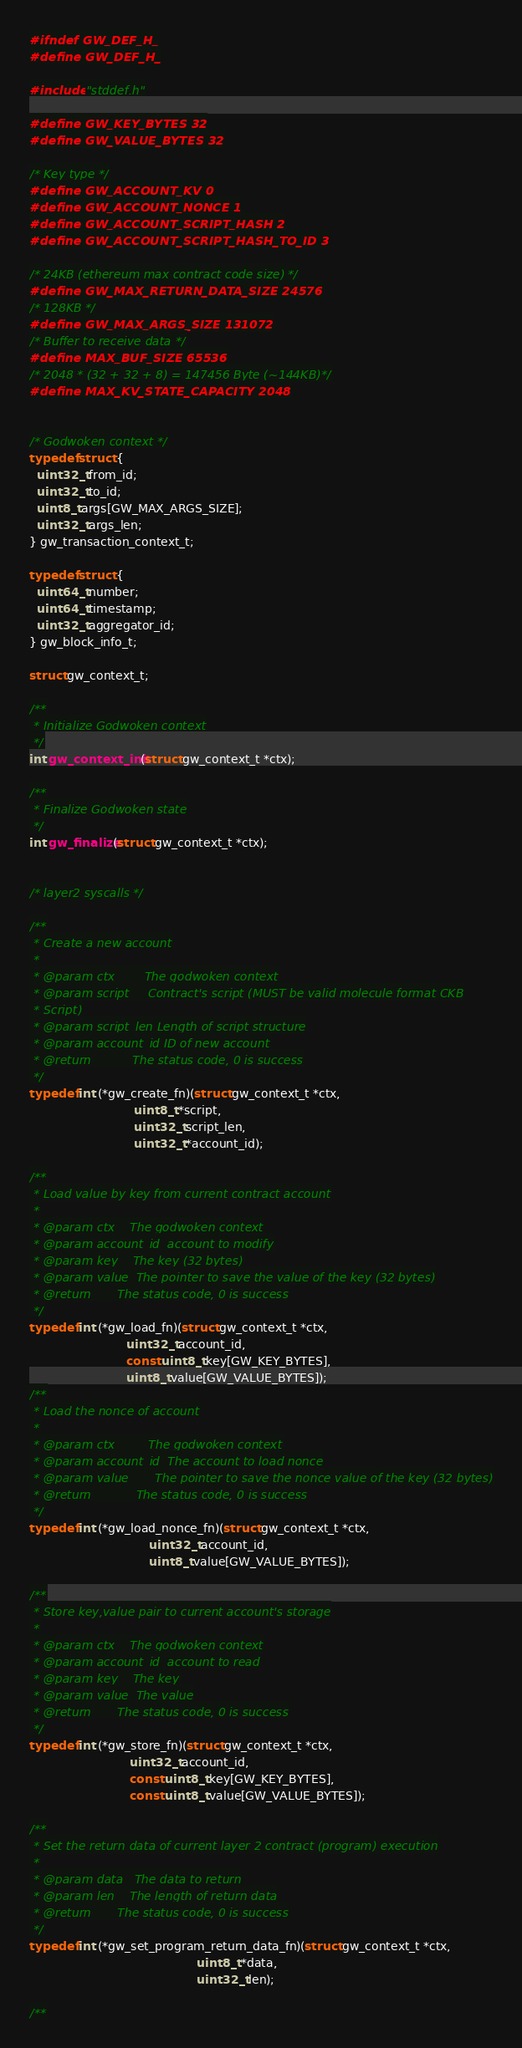<code> <loc_0><loc_0><loc_500><loc_500><_C_>#ifndef GW_DEF_H_
#define GW_DEF_H_

#include "stddef.h"

#define GW_KEY_BYTES 32
#define GW_VALUE_BYTES 32

/* Key type */
#define GW_ACCOUNT_KV 0
#define GW_ACCOUNT_NONCE 1
#define GW_ACCOUNT_SCRIPT_HASH 2
#define GW_ACCOUNT_SCRIPT_HASH_TO_ID 3

/* 24KB (ethereum max contract code size) */
#define GW_MAX_RETURN_DATA_SIZE 24576
/* 128KB */
#define GW_MAX_ARGS_SIZE 131072
/* Buffer to receive data */
#define MAX_BUF_SIZE 65536
/* 2048 * (32 + 32 + 8) = 147456 Byte (~144KB)*/
#define MAX_KV_STATE_CAPACITY 2048


/* Godwoken context */
typedef struct {
  uint32_t from_id;
  uint32_t to_id;
  uint8_t args[GW_MAX_ARGS_SIZE];
  uint32_t args_len;
} gw_transaction_context_t;

typedef struct {
  uint64_t number;
  uint64_t timestamp;
  uint32_t aggregator_id;
} gw_block_info_t;

struct gw_context_t;

/**
 * Initialize Godwoken context
 */
int gw_context_init(struct gw_context_t *ctx);

/**
 * Finalize Godwoken state
 */
int gw_finalize(struct gw_context_t *ctx);


/* layer2 syscalls */

/**
 * Create a new account
 *
 * @param ctx        The godwoken context
 * @param script     Contract's script (MUST be valid molecule format CKB
 * Script)
 * @param script_len Length of script structure
 * @param account_id ID of new account
 * @return           The status code, 0 is success
 */
typedef int (*gw_create_fn)(struct gw_context_t *ctx,
                            uint8_t *script,
                            uint32_t script_len,
                            uint32_t *account_id);

/**
 * Load value by key from current contract account
 *
 * @param ctx    The godwoken context
 * @param account_id  account to modify
 * @param key    The key (32 bytes)
 * @param value  The pointer to save the value of the key (32 bytes)
 * @return       The status code, 0 is success
 */
typedef int (*gw_load_fn)(struct gw_context_t *ctx,
                          uint32_t account_id,
                          const uint8_t key[GW_KEY_BYTES],
                          uint8_t value[GW_VALUE_BYTES]);
/**
 * Load the nonce of account
 *
 * @param ctx         The godwoken context
 * @param account_id  The account to load nonce
 * @param value       The pointer to save the nonce value of the key (32 bytes)
 * @return            The status code, 0 is success
 */
typedef int (*gw_load_nonce_fn)(struct gw_context_t *ctx,
                                uint32_t account_id,
                                uint8_t value[GW_VALUE_BYTES]);

/**
 * Store key,value pair to current account's storage
 *
 * @param ctx    The godwoken context
 * @param account_id  account to read
 * @param key    The key
 * @param value  The value
 * @return       The status code, 0 is success
 */
typedef int (*gw_store_fn)(struct gw_context_t *ctx,
                           uint32_t account_id,
                           const uint8_t key[GW_KEY_BYTES],
                           const uint8_t value[GW_VALUE_BYTES]);

/**
 * Set the return data of current layer 2 contract (program) execution
 *
 * @param data   The data to return
 * @param len    The length of return data
 * @return       The status code, 0 is success
 */
typedef int (*gw_set_program_return_data_fn)(struct gw_context_t *ctx,
                                             uint8_t *data,
                                             uint32_t len);

/**</code> 